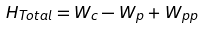<formula> <loc_0><loc_0><loc_500><loc_500>H _ { T o t a l } = W _ { c } - W _ { p } + W _ { p p }</formula> 